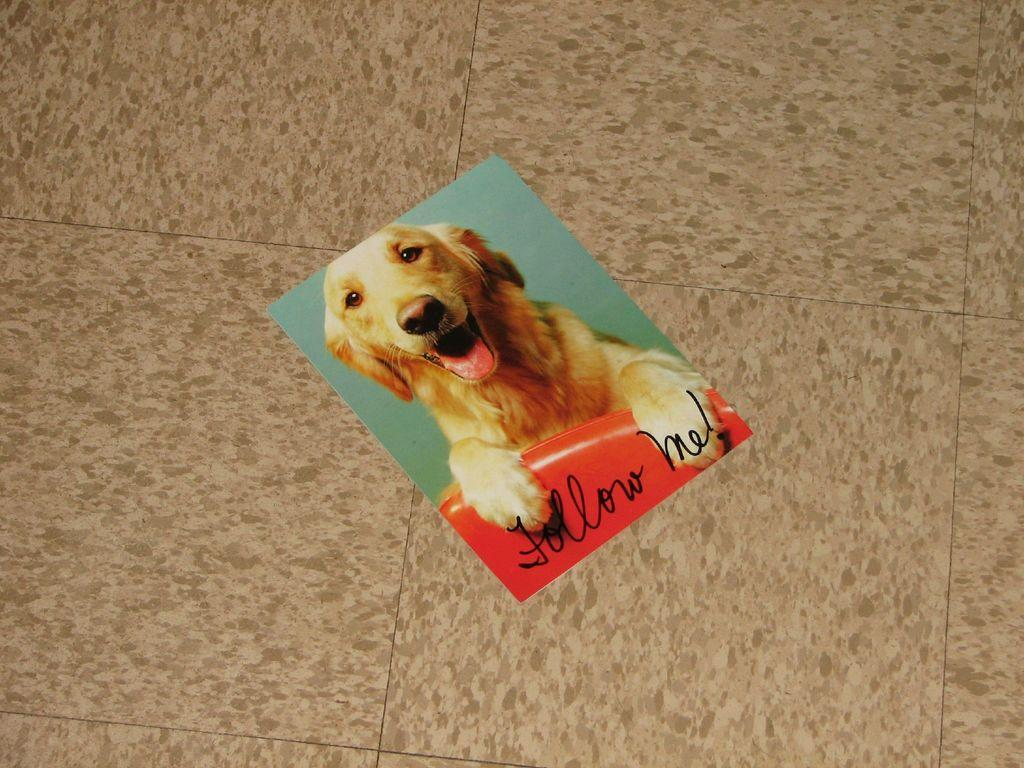What is depicted in the image? There is a photograph of a dog in the image. Where is the photograph located? The photograph is present on the floor. What type of liquid can be seen spilling from the dog's mouth in the image? There is no liquid spilling from the dog's mouth in the image; it is a photograph of a dog. Is there a sail visible in the image? No, there is no sail present in the image. 